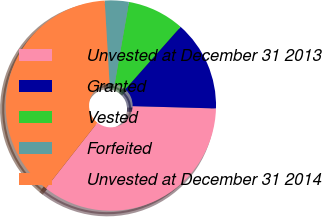Convert chart. <chart><loc_0><loc_0><loc_500><loc_500><pie_chart><fcel>Unvested at December 31 2013<fcel>Granted<fcel>Vested<fcel>Forfeited<fcel>Unvested at December 31 2014<nl><fcel>35.17%<fcel>13.9%<fcel>8.77%<fcel>3.7%<fcel>38.46%<nl></chart> 